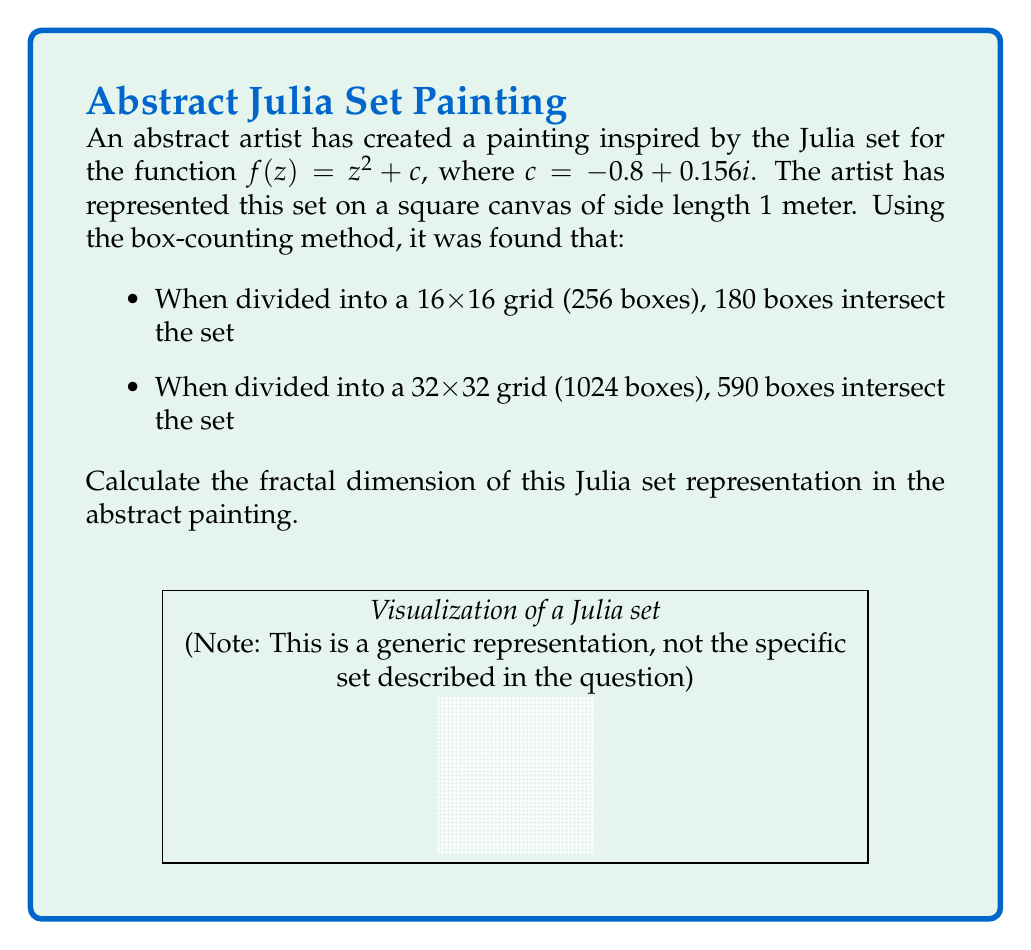Provide a solution to this math problem. To calculate the fractal dimension using the box-counting method, we'll follow these steps:

1) The box-counting dimension is defined as:

   $$D = \lim_{\epsilon \to 0} \frac{\log N(\epsilon)}{\log(1/\epsilon)}$$

   where $N(\epsilon)$ is the number of boxes of side length $\epsilon$ that intersect the set.

2) We have two data points:
   - For $\epsilon_1 = 1/16$, $N(\epsilon_1) = 180$
   - For $\epsilon_2 = 1/32$, $N(\epsilon_2) = 590$

3) We can approximate the fractal dimension using these two scales:

   $$D \approx \frac{\log(N(\epsilon_2)) - \log(N(\epsilon_1))}{\log(1/\epsilon_2) - \log(1/\epsilon_1)}$$

4) Substituting our values:

   $$D \approx \frac{\log(590) - \log(180)}{\log(32) - \log(16)}$$

5) Simplify:
   
   $$D \approx \frac{\log(590/180)}{\log(2)}$$

6) Calculate:

   $$D \approx \frac{\log(3.2778)}{\log(2)} \approx 1.7136$$

Therefore, the approximate fractal dimension of the Julia set representation in the abstract painting is 1.7136.
Answer: $1.7136$ 